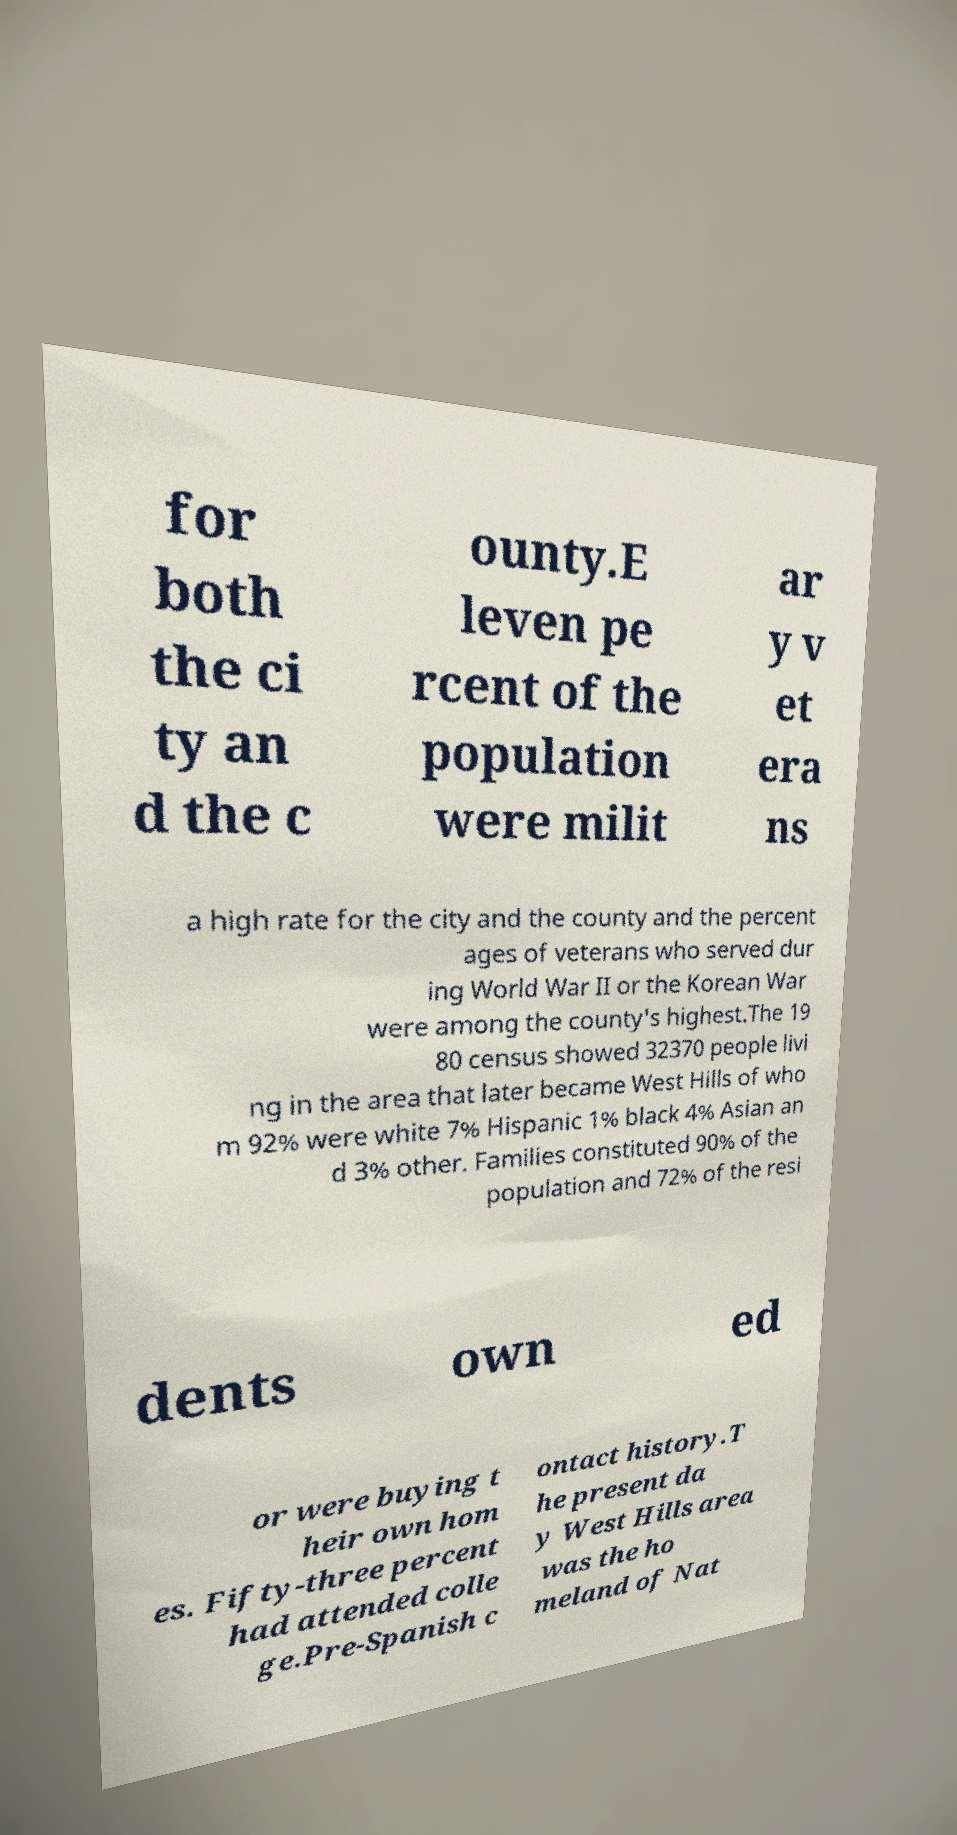For documentation purposes, I need the text within this image transcribed. Could you provide that? for both the ci ty an d the c ounty.E leven pe rcent of the population were milit ar y v et era ns a high rate for the city and the county and the percent ages of veterans who served dur ing World War II or the Korean War were among the county's highest.The 19 80 census showed 32370 people livi ng in the area that later became West Hills of who m 92% were white 7% Hispanic 1% black 4% Asian an d 3% other. Families constituted 90% of the population and 72% of the resi dents own ed or were buying t heir own hom es. Fifty-three percent had attended colle ge.Pre-Spanish c ontact history.T he present da y West Hills area was the ho meland of Nat 